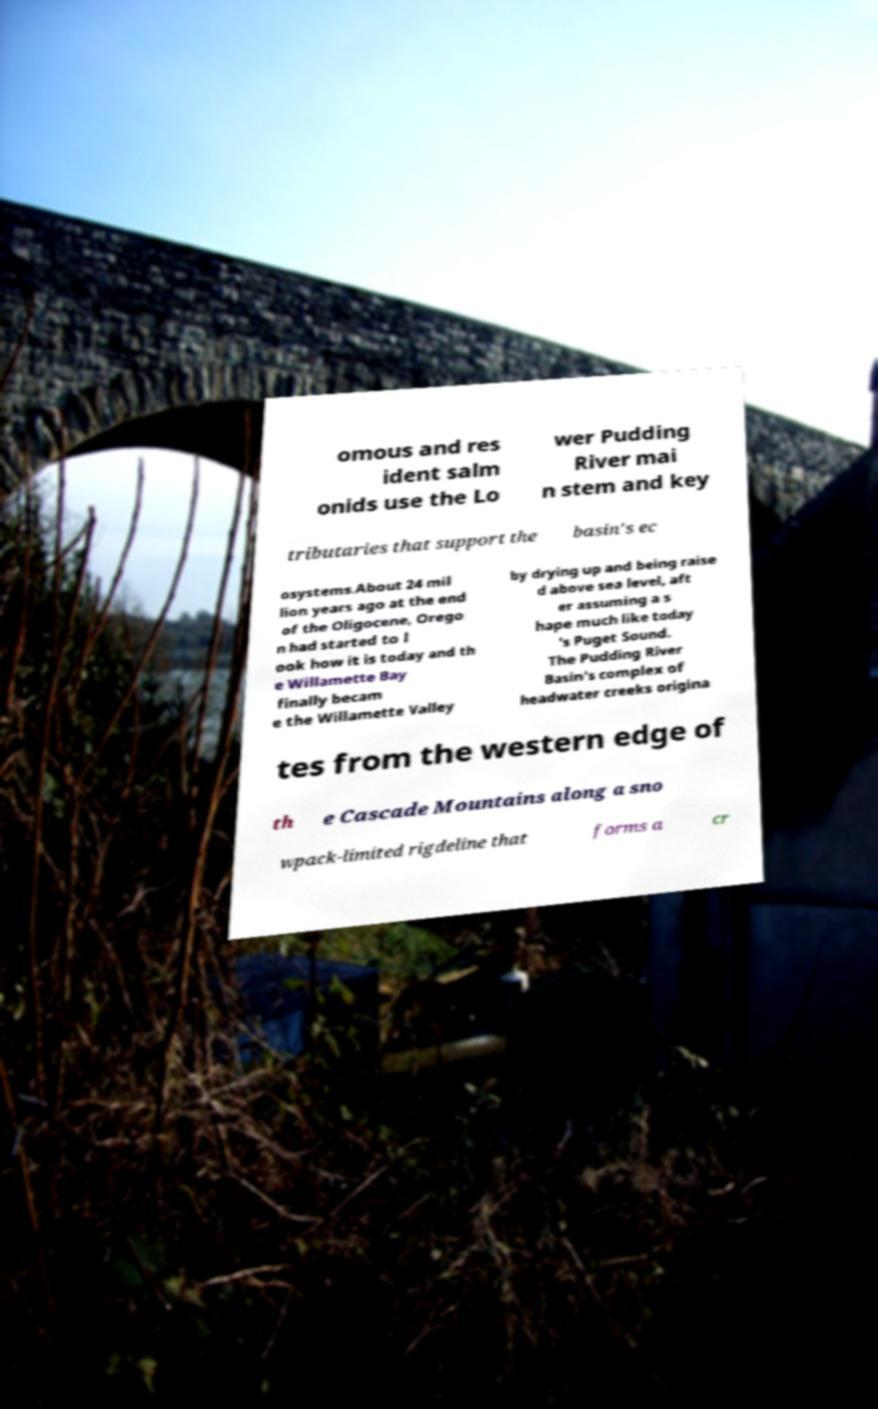What messages or text are displayed in this image? I need them in a readable, typed format. omous and res ident salm onids use the Lo wer Pudding River mai n stem and key tributaries that support the basin's ec osystems.About 24 mil lion years ago at the end of the Oligocene, Orego n had started to l ook how it is today and th e Willamette Bay finally becam e the Willamette Valley by drying up and being raise d above sea level, aft er assuming a s hape much like today 's Puget Sound. The Pudding River Basin's complex of headwater creeks origina tes from the western edge of th e Cascade Mountains along a sno wpack-limited rigdeline that forms a cr 